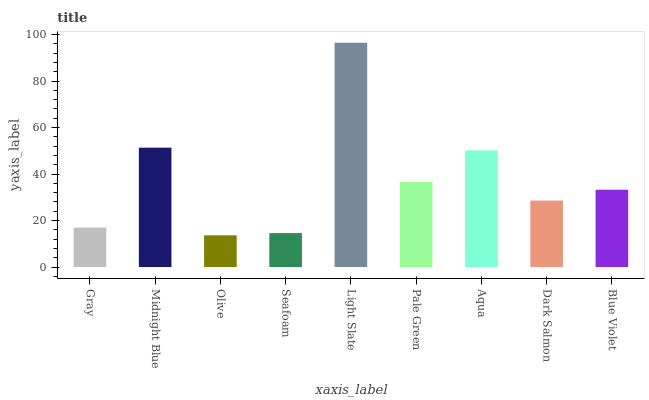Is Midnight Blue the minimum?
Answer yes or no. No. Is Midnight Blue the maximum?
Answer yes or no. No. Is Midnight Blue greater than Gray?
Answer yes or no. Yes. Is Gray less than Midnight Blue?
Answer yes or no. Yes. Is Gray greater than Midnight Blue?
Answer yes or no. No. Is Midnight Blue less than Gray?
Answer yes or no. No. Is Blue Violet the high median?
Answer yes or no. Yes. Is Blue Violet the low median?
Answer yes or no. Yes. Is Olive the high median?
Answer yes or no. No. Is Midnight Blue the low median?
Answer yes or no. No. 